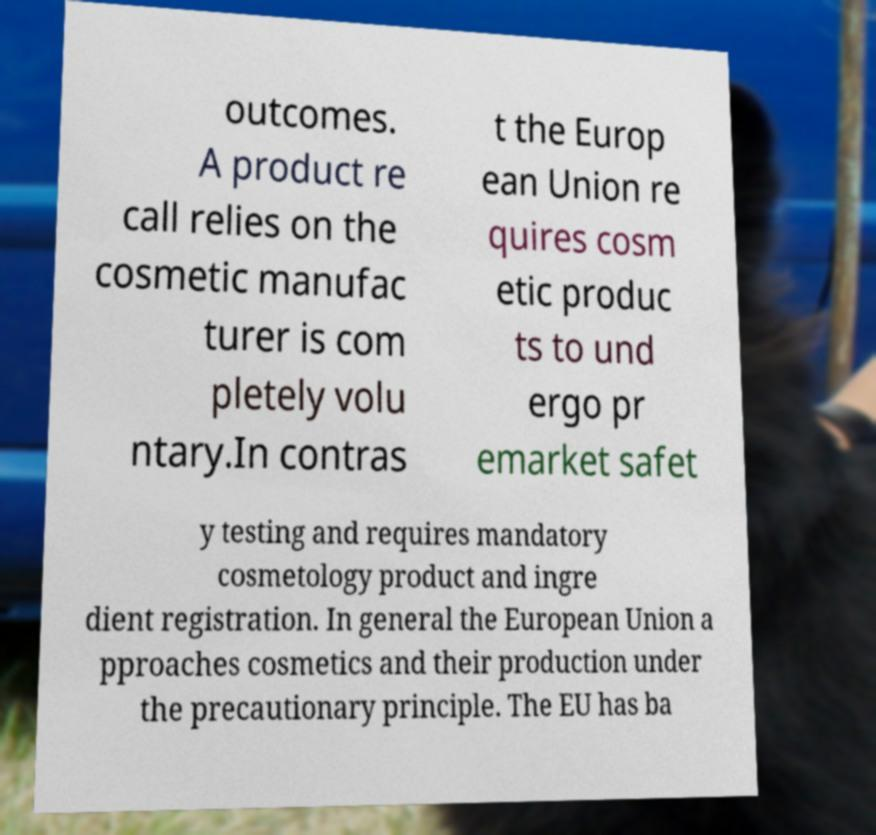Can you read and provide the text displayed in the image?This photo seems to have some interesting text. Can you extract and type it out for me? outcomes. A product re call relies on the cosmetic manufac turer is com pletely volu ntary.In contras t the Europ ean Union re quires cosm etic produc ts to und ergo pr emarket safet y testing and requires mandatory cosmetology product and ingre dient registration. In general the European Union a pproaches cosmetics and their production under the precautionary principle. The EU has ba 